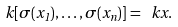Convert formula to latex. <formula><loc_0><loc_0><loc_500><loc_500>k [ \sigma ( x _ { 1 } ) , \dots , \sigma ( x _ { n } ) ] = \ k x .</formula> 